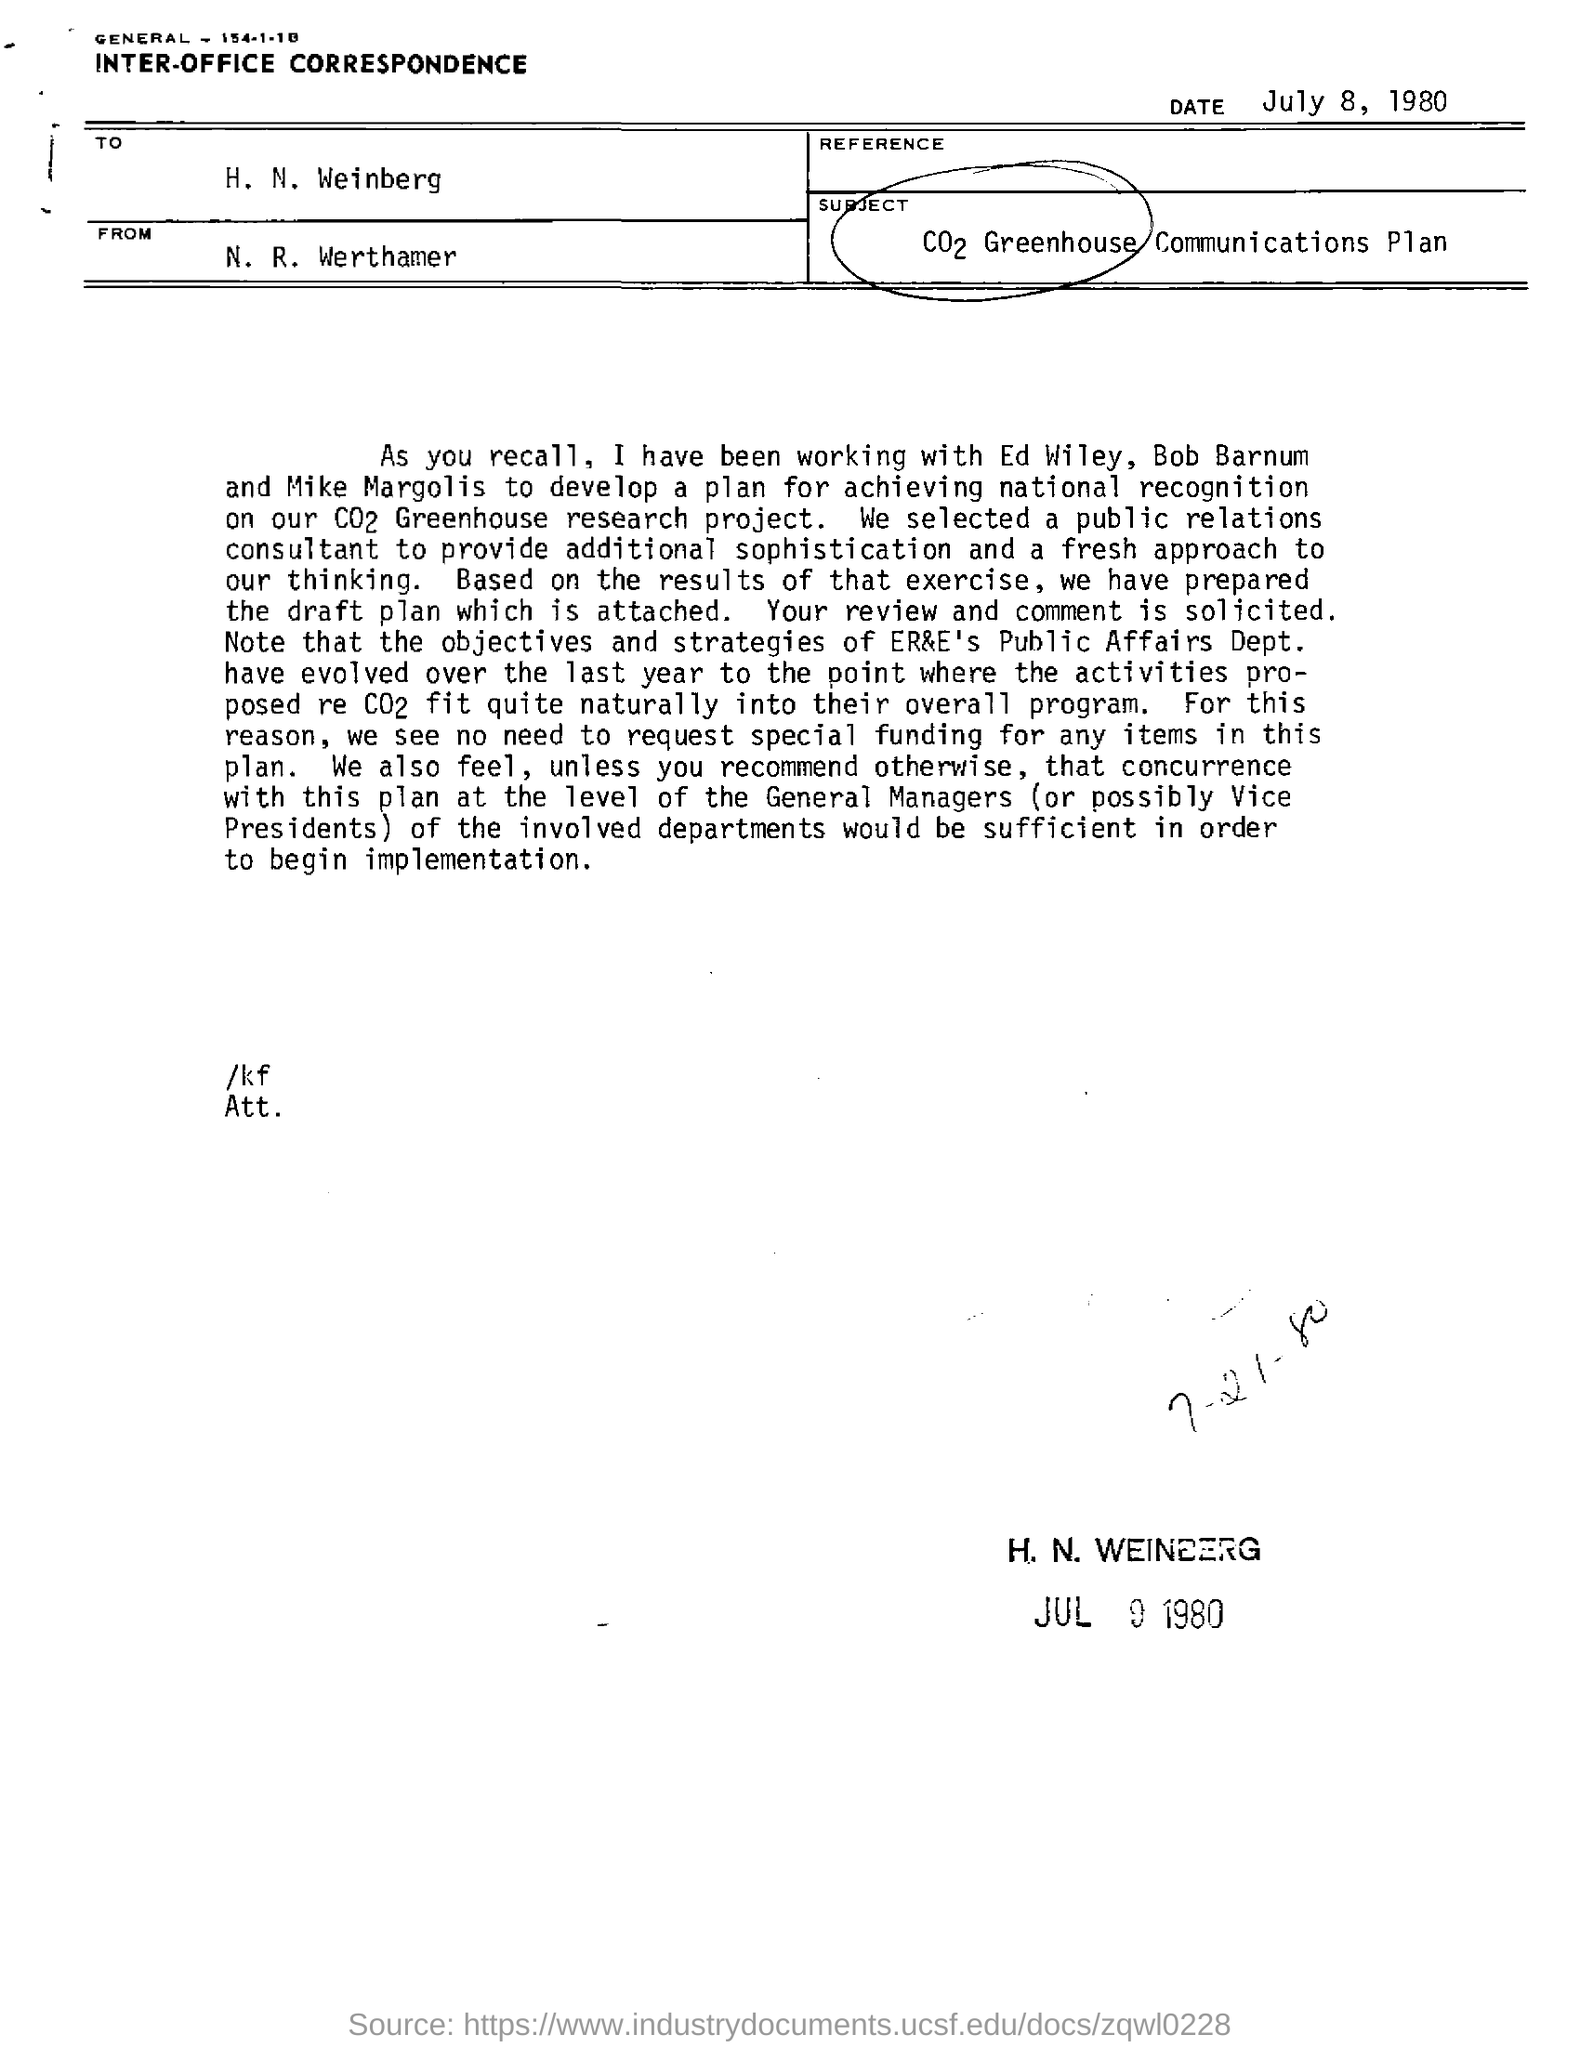Identify some key points in this picture. The document is addressed to H. N. Weinberg. The document is from N. R. Werthamer. This is a document of inter-office correspondence. The document is dated July 8, 1980. 